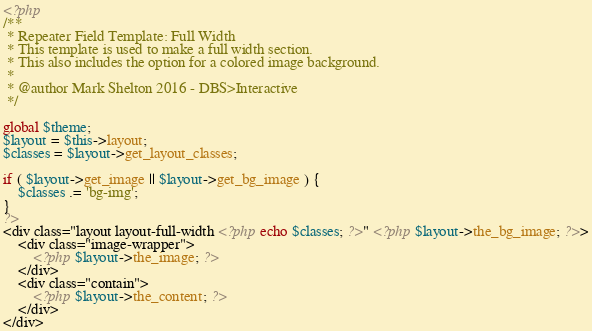<code> <loc_0><loc_0><loc_500><loc_500><_PHP_><?php
/**
 * Repeater Field Template: Full Width
 * This template is used to make a full width section.
 * This also includes the option for a colored image background.
 *
 * @author Mark Shelton 2016 - DBS>Interactive
 */

global $theme;
$layout = $this->layout;
$classes = $layout->get_layout_classes;

if ( $layout->get_image || $layout->get_bg_image ) {
	$classes .= 'bg-img';
}
?>
<div class="layout layout-full-width <?php echo $classes; ?>" <?php $layout->the_bg_image; ?>>
	<div class="image-wrapper">
		<?php $layout->the_image; ?>
	</div>
	<div class="contain">
		<?php $layout->the_content; ?>
	</div>
</div>
</code> 